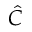<formula> <loc_0><loc_0><loc_500><loc_500>\hat { C }</formula> 